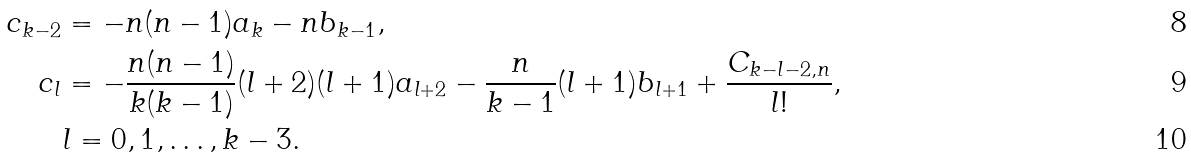<formula> <loc_0><loc_0><loc_500><loc_500>c _ { k - 2 } & = - n ( n - 1 ) a _ { k } - n b _ { k - 1 } , \\ c _ { l } & = - \frac { n ( n - 1 ) } { k ( k - 1 ) } ( l + 2 ) ( l + 1 ) a _ { l + 2 } - \frac { n } { k - 1 } ( l + 1 ) b _ { l + 1 } + \frac { C _ { k - l - 2 , n } } { l ! } , \\ & l = 0 , 1 , \dots , k - 3 .</formula> 